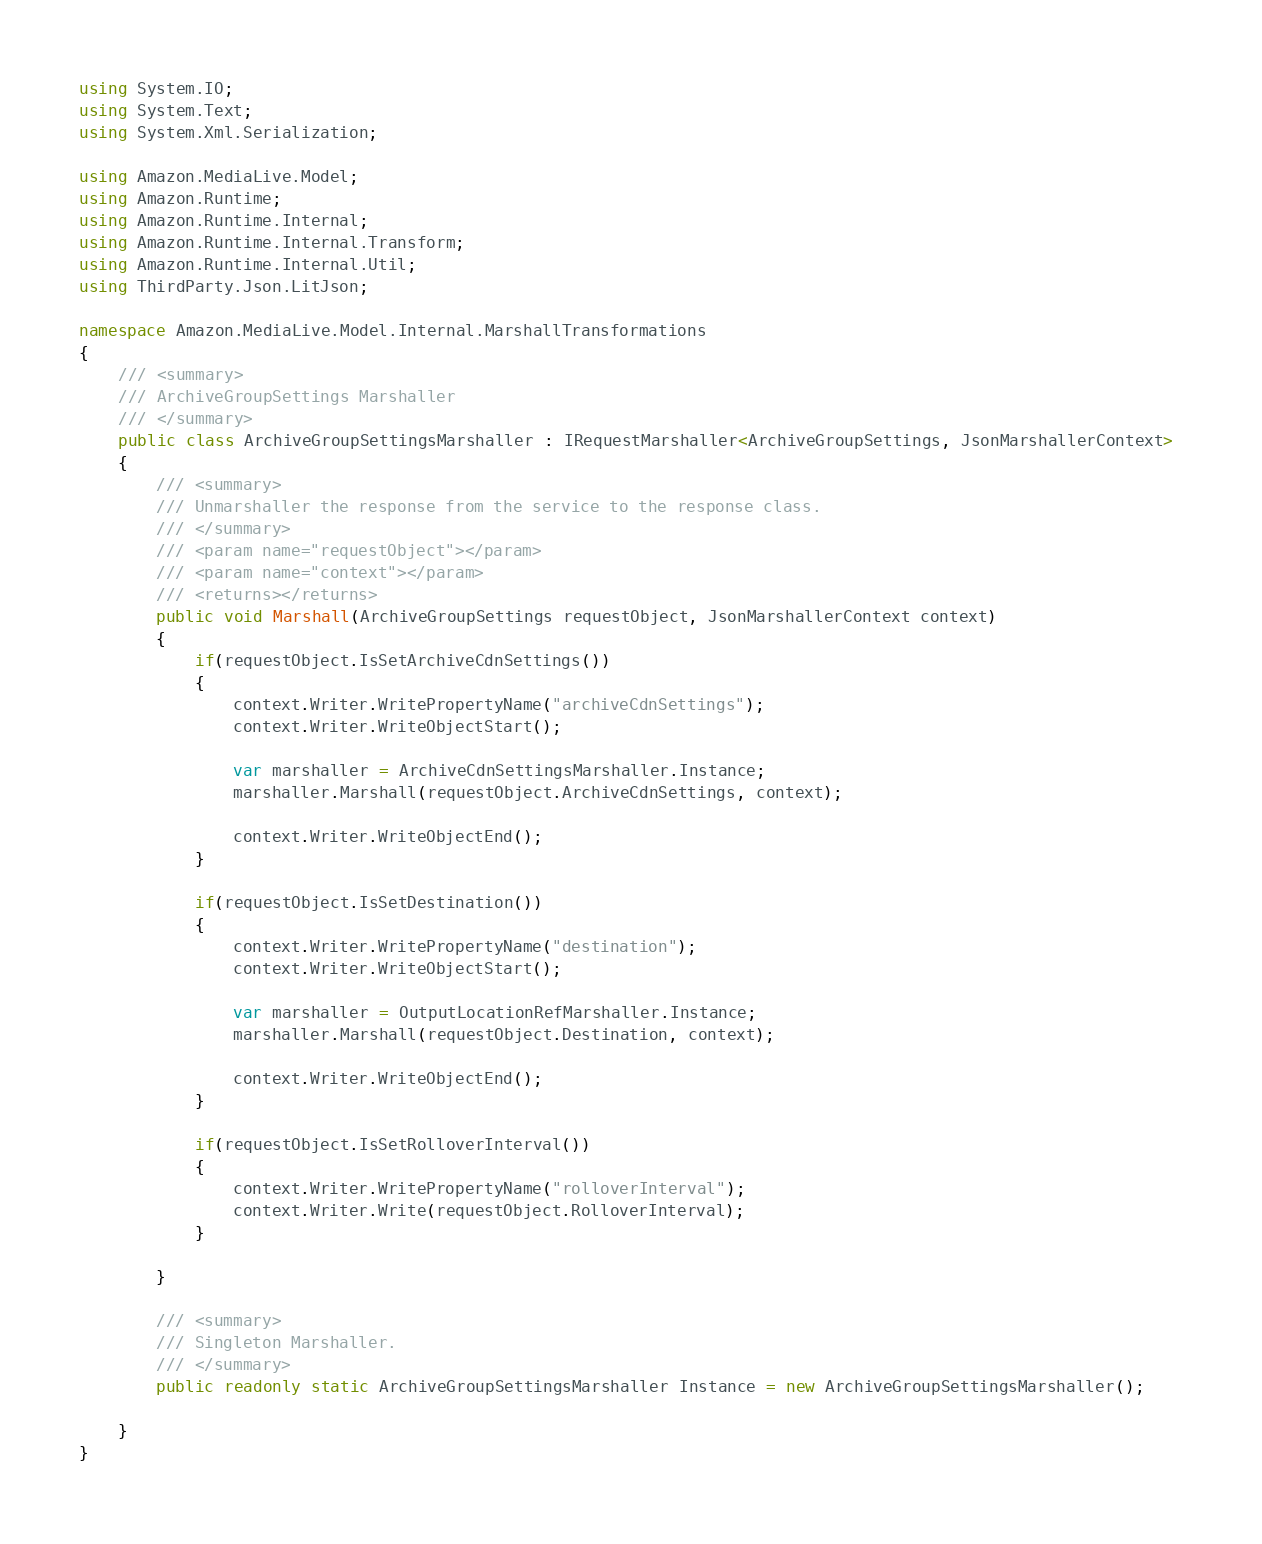Convert code to text. <code><loc_0><loc_0><loc_500><loc_500><_C#_>using System.IO;
using System.Text;
using System.Xml.Serialization;

using Amazon.MediaLive.Model;
using Amazon.Runtime;
using Amazon.Runtime.Internal;
using Amazon.Runtime.Internal.Transform;
using Amazon.Runtime.Internal.Util;
using ThirdParty.Json.LitJson;

namespace Amazon.MediaLive.Model.Internal.MarshallTransformations
{
    /// <summary>
    /// ArchiveGroupSettings Marshaller
    /// </summary>
    public class ArchiveGroupSettingsMarshaller : IRequestMarshaller<ArchiveGroupSettings, JsonMarshallerContext> 
    {
        /// <summary>
        /// Unmarshaller the response from the service to the response class.
        /// </summary>  
        /// <param name="requestObject"></param>
        /// <param name="context"></param>
        /// <returns></returns>
        public void Marshall(ArchiveGroupSettings requestObject, JsonMarshallerContext context)
        {
            if(requestObject.IsSetArchiveCdnSettings())
            {
                context.Writer.WritePropertyName("archiveCdnSettings");
                context.Writer.WriteObjectStart();

                var marshaller = ArchiveCdnSettingsMarshaller.Instance;
                marshaller.Marshall(requestObject.ArchiveCdnSettings, context);

                context.Writer.WriteObjectEnd();
            }

            if(requestObject.IsSetDestination())
            {
                context.Writer.WritePropertyName("destination");
                context.Writer.WriteObjectStart();

                var marshaller = OutputLocationRefMarshaller.Instance;
                marshaller.Marshall(requestObject.Destination, context);

                context.Writer.WriteObjectEnd();
            }

            if(requestObject.IsSetRolloverInterval())
            {
                context.Writer.WritePropertyName("rolloverInterval");
                context.Writer.Write(requestObject.RolloverInterval);
            }

        }

        /// <summary>
        /// Singleton Marshaller.
        /// </summary>
        public readonly static ArchiveGroupSettingsMarshaller Instance = new ArchiveGroupSettingsMarshaller();

    }
}</code> 